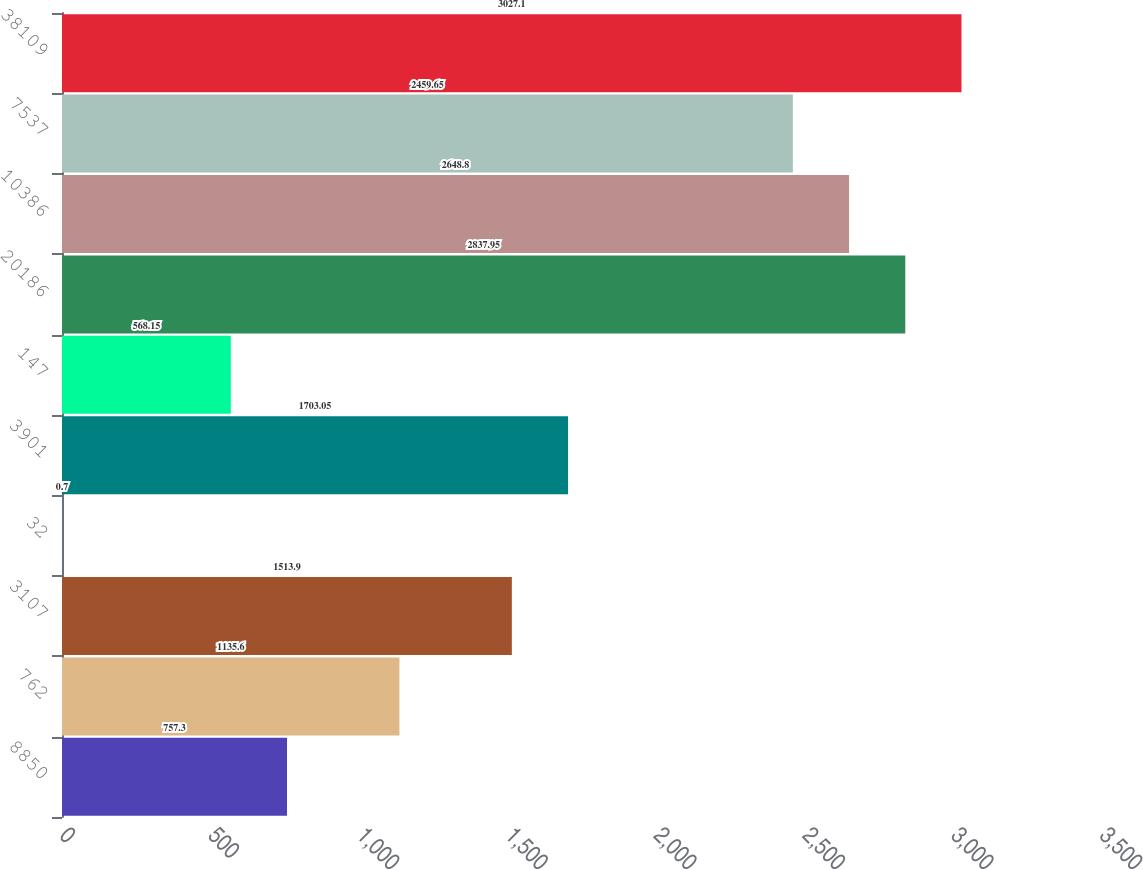Convert chart to OTSL. <chart><loc_0><loc_0><loc_500><loc_500><bar_chart><fcel>8850<fcel>762<fcel>3107<fcel>32<fcel>3901<fcel>147<fcel>20186<fcel>10386<fcel>7537<fcel>38109<nl><fcel>757.3<fcel>1135.6<fcel>1513.9<fcel>0.7<fcel>1703.05<fcel>568.15<fcel>2837.95<fcel>2648.8<fcel>2459.65<fcel>3027.1<nl></chart> 